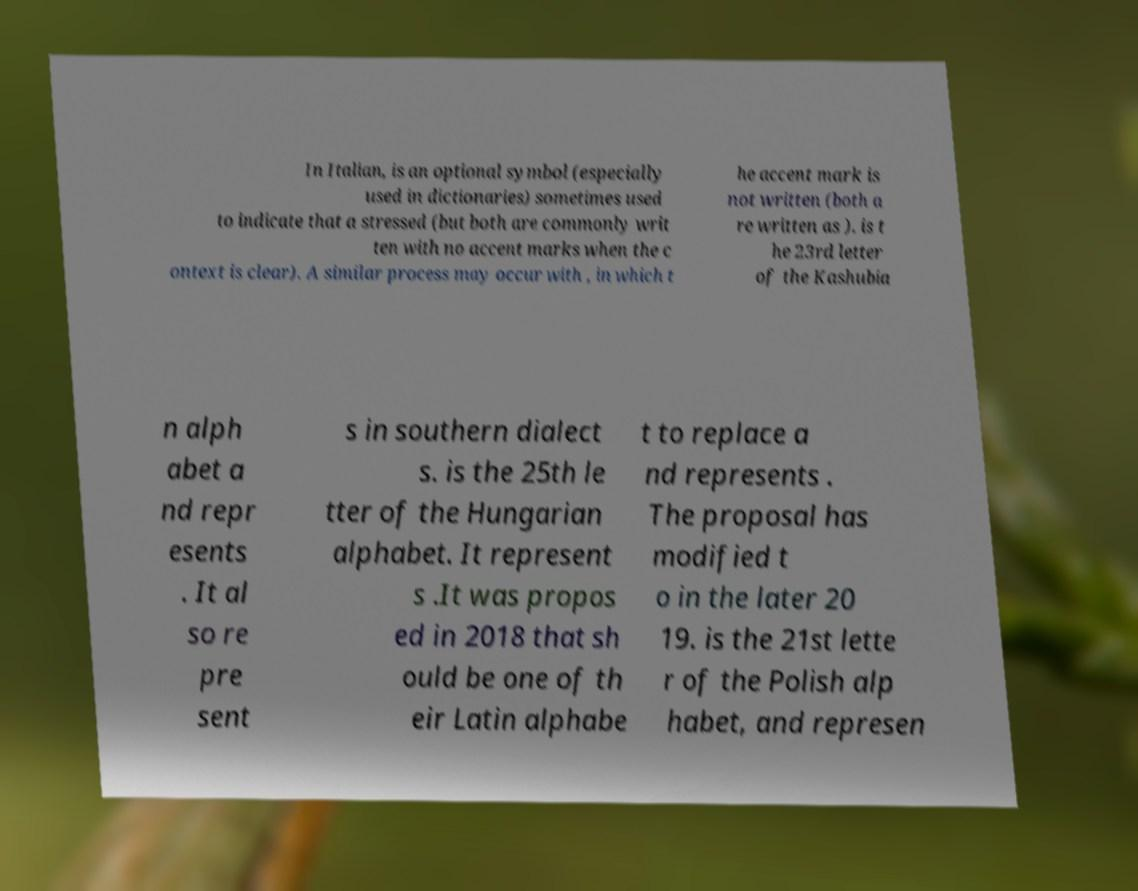Please identify and transcribe the text found in this image. In Italian, is an optional symbol (especially used in dictionaries) sometimes used to indicate that a stressed (but both are commonly writ ten with no accent marks when the c ontext is clear). A similar process may occur with , in which t he accent mark is not written (both a re written as ). is t he 23rd letter of the Kashubia n alph abet a nd repr esents . It al so re pre sent s in southern dialect s. is the 25th le tter of the Hungarian alphabet. It represent s .It was propos ed in 2018 that sh ould be one of th eir Latin alphabe t to replace a nd represents . The proposal has modified t o in the later 20 19. is the 21st lette r of the Polish alp habet, and represen 